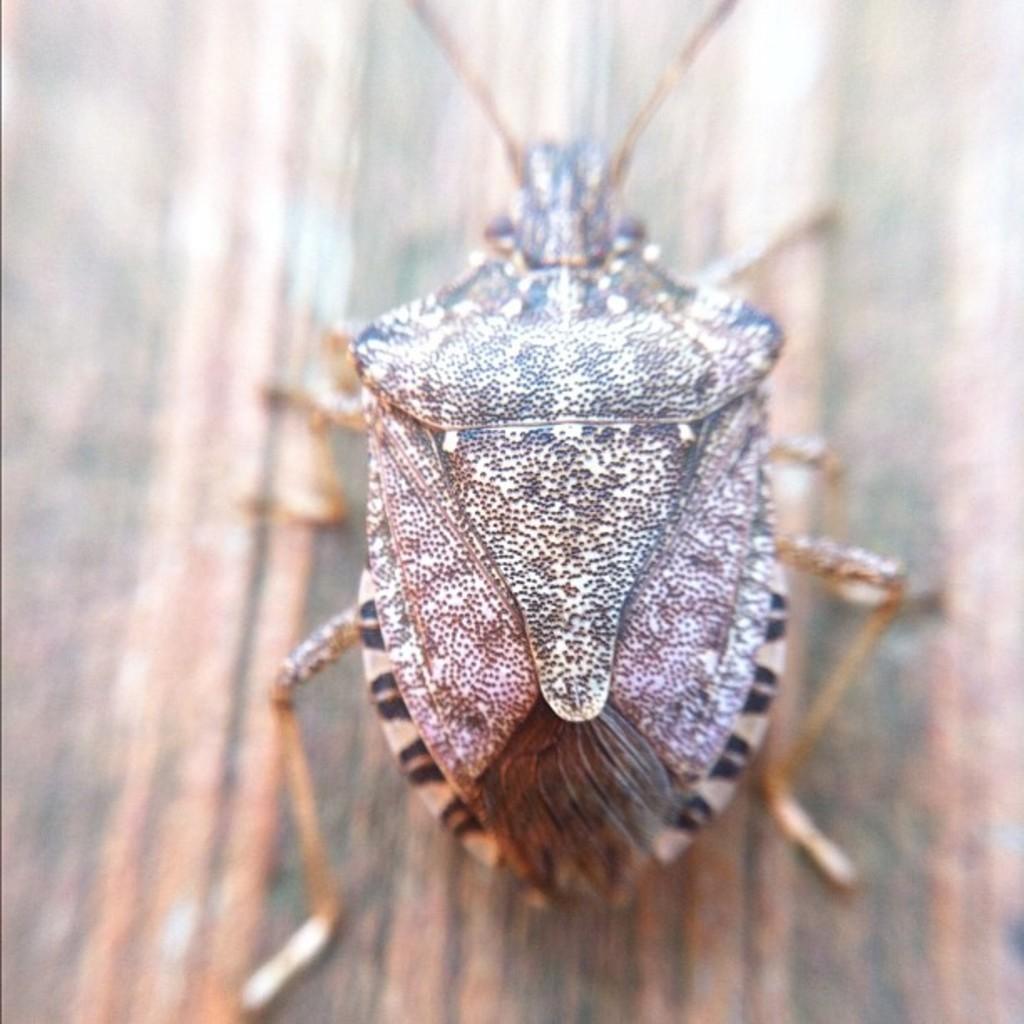How would you summarize this image in a sentence or two? In the center of the image we can see one wood. On the wood,we can see one insect,which is in cream and black color. 